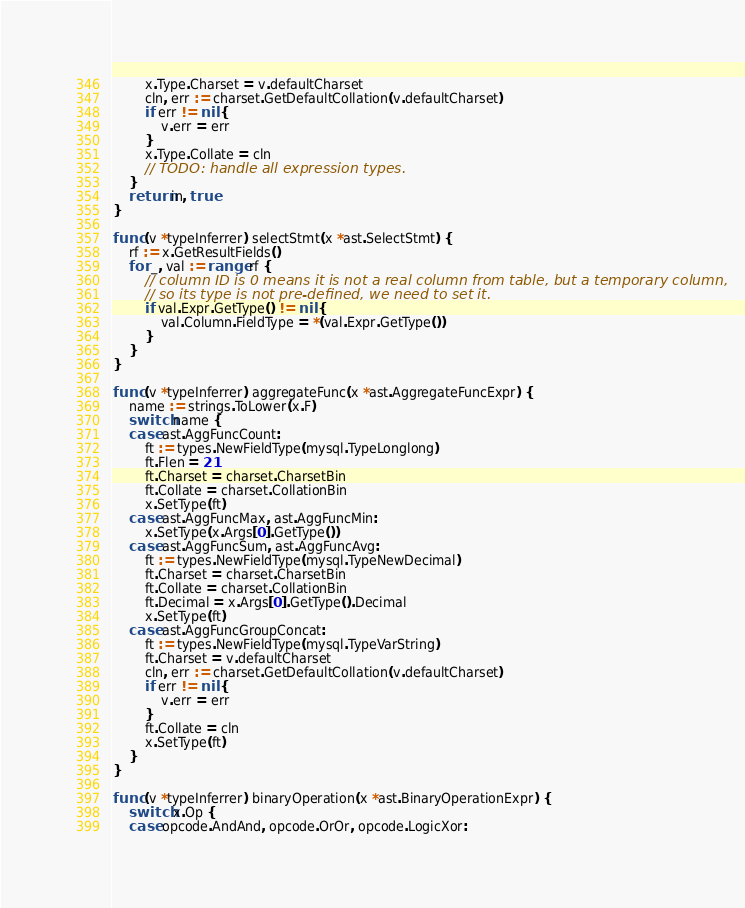Convert code to text. <code><loc_0><loc_0><loc_500><loc_500><_Go_>		x.Type.Charset = v.defaultCharset
		cln, err := charset.GetDefaultCollation(v.defaultCharset)
		if err != nil {
			v.err = err
		}
		x.Type.Collate = cln
		// TODO: handle all expression types.
	}
	return in, true
}

func (v *typeInferrer) selectStmt(x *ast.SelectStmt) {
	rf := x.GetResultFields()
	for _, val := range rf {
		// column ID is 0 means it is not a real column from table, but a temporary column,
		// so its type is not pre-defined, we need to set it.
		if val.Expr.GetType() != nil {
			val.Column.FieldType = *(val.Expr.GetType())
		}
	}
}

func (v *typeInferrer) aggregateFunc(x *ast.AggregateFuncExpr) {
	name := strings.ToLower(x.F)
	switch name {
	case ast.AggFuncCount:
		ft := types.NewFieldType(mysql.TypeLonglong)
		ft.Flen = 21
		ft.Charset = charset.CharsetBin
		ft.Collate = charset.CollationBin
		x.SetType(ft)
	case ast.AggFuncMax, ast.AggFuncMin:
		x.SetType(x.Args[0].GetType())
	case ast.AggFuncSum, ast.AggFuncAvg:
		ft := types.NewFieldType(mysql.TypeNewDecimal)
		ft.Charset = charset.CharsetBin
		ft.Collate = charset.CollationBin
		ft.Decimal = x.Args[0].GetType().Decimal
		x.SetType(ft)
	case ast.AggFuncGroupConcat:
		ft := types.NewFieldType(mysql.TypeVarString)
		ft.Charset = v.defaultCharset
		cln, err := charset.GetDefaultCollation(v.defaultCharset)
		if err != nil {
			v.err = err
		}
		ft.Collate = cln
		x.SetType(ft)
	}
}

func (v *typeInferrer) binaryOperation(x *ast.BinaryOperationExpr) {
	switch x.Op {
	case opcode.AndAnd, opcode.OrOr, opcode.LogicXor:</code> 